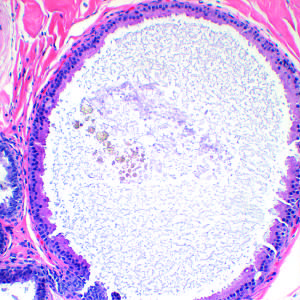s the prominent cell in the center field a common feature of nonproliferative breast disease?
Answer the question using a single word or phrase. No 